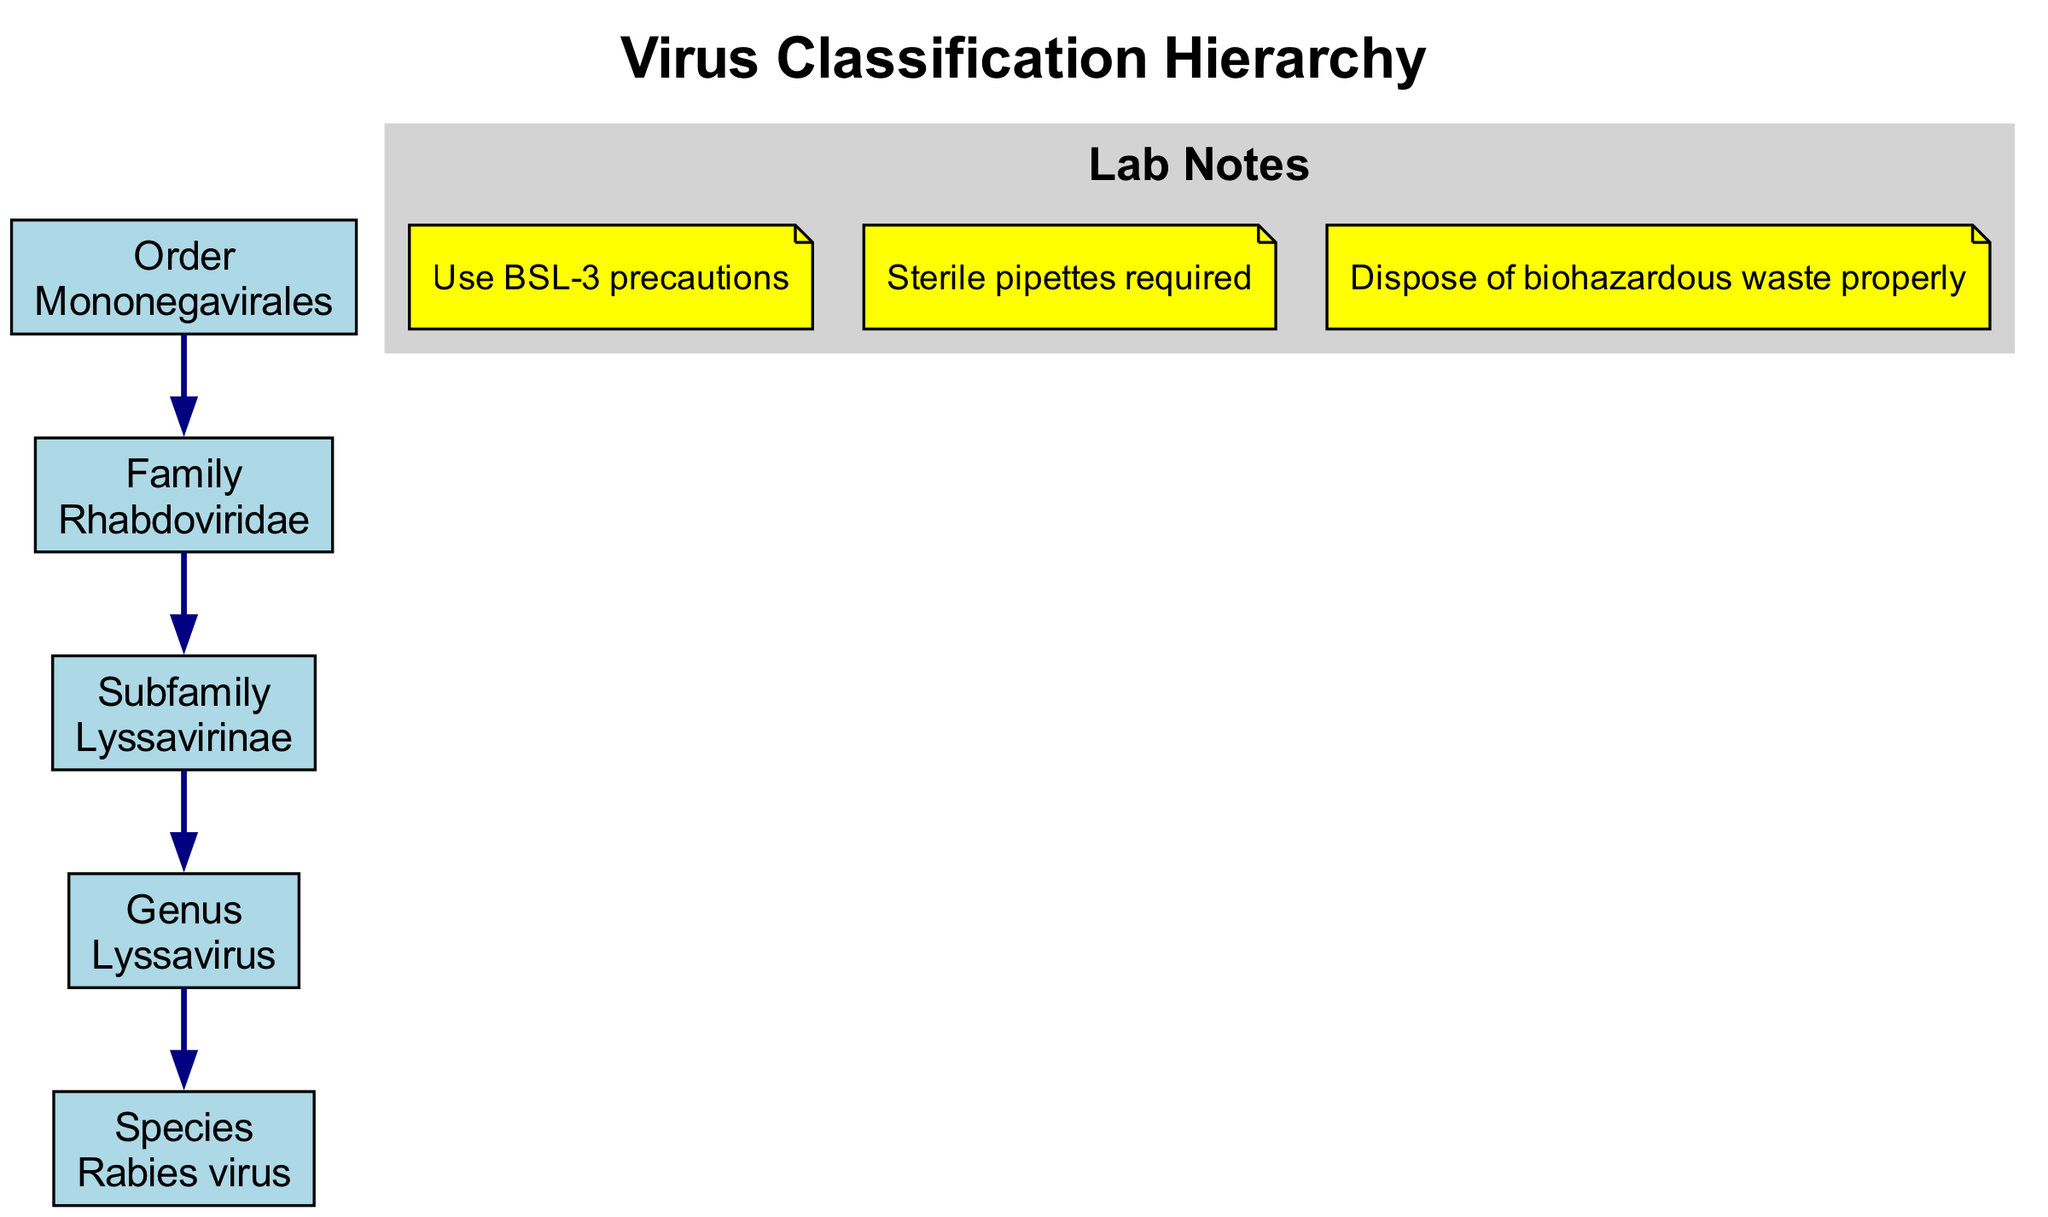What is the highest level in the virus classification hierarchy? The highest level shown in the diagram is "Order", which is the first node from the top.
Answer: Order Which virus family is an example under the Order Mononegavirales? In the hierarchy diagram, the Family listed under the Order Mononegavirales is "Rhabdoviridae".
Answer: Rhabdoviridae How many levels are represented in the virus classification hierarchy? By counting the levels listed from Order to Species, there are five levels represented: Order, Family, Subfamily, Genus, and Species.
Answer: 5 Which genus is associated with the species Rabies virus? The diagram indicates that the "Genus" associated with the species Rabies virus is "Lyssavirus".
Answer: Lyssavirus What type of precautions should be taken when working with viruses classified under this hierarchy? The lab notes on the diagram state that "Use BSL-3 precautions" must be followed, which is a specific biosafety level.
Answer: BSL-3 What relationship exists between the Family and the Genus in this hierarchy? The relationship is one of inclusion; the Family Rhabdoviridae contains the Genus Lyssavirus, indicating a hierarchical structure where the Genus is a subset of the Family.
Answer: Inclusion What example of a species is classified under the Genus Lyssavirus? The species classified under the Genus Lyssavirus in the hierarchy is the "Rabies virus".
Answer: Rabies virus Which lab note emphasizes the importance of waste disposal? The lab note that highlights the importance of waste disposal is "Dispose of biohazardous waste properly", as it indicates a necessary action when handling hazardous materials in the lab.
Answer: Dispose of biohazardous waste properly 